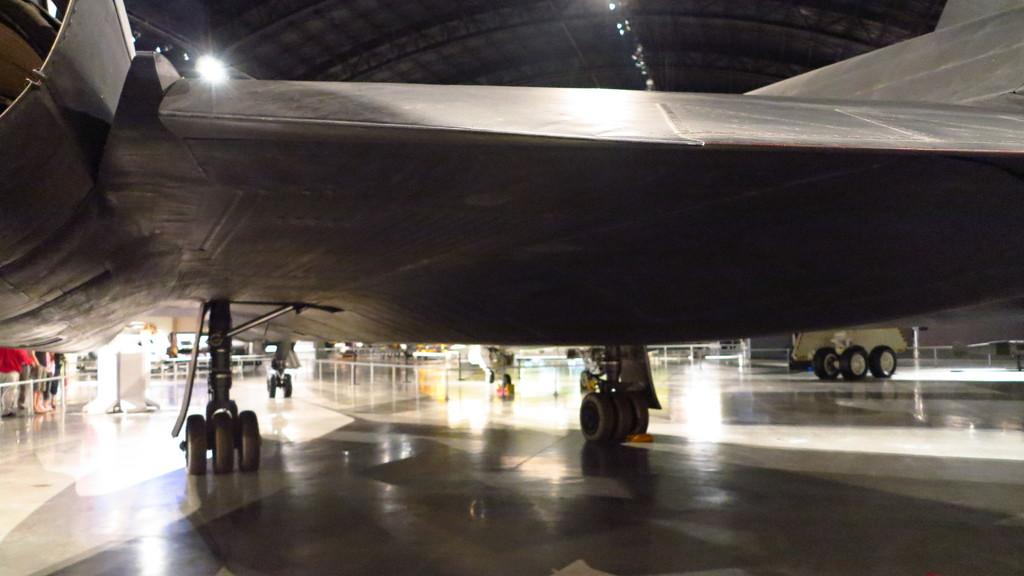What is the main subject of the image? The main subject of the image is an airplane with wheels on the ground. What else can be seen in the image besides the airplane? There is a fence, people, some objects, a roof, and lights visible in the image. Can you describe the fence in the image? The fence is a structure that can be seen in the image. What is the background of the image like? The background of the image includes a roof and lights. What type of crack can be seen in the image? There is no crack present in the image. Can you tell me how much credit the people in the image have? There is no information about the credit of the people in the image. 